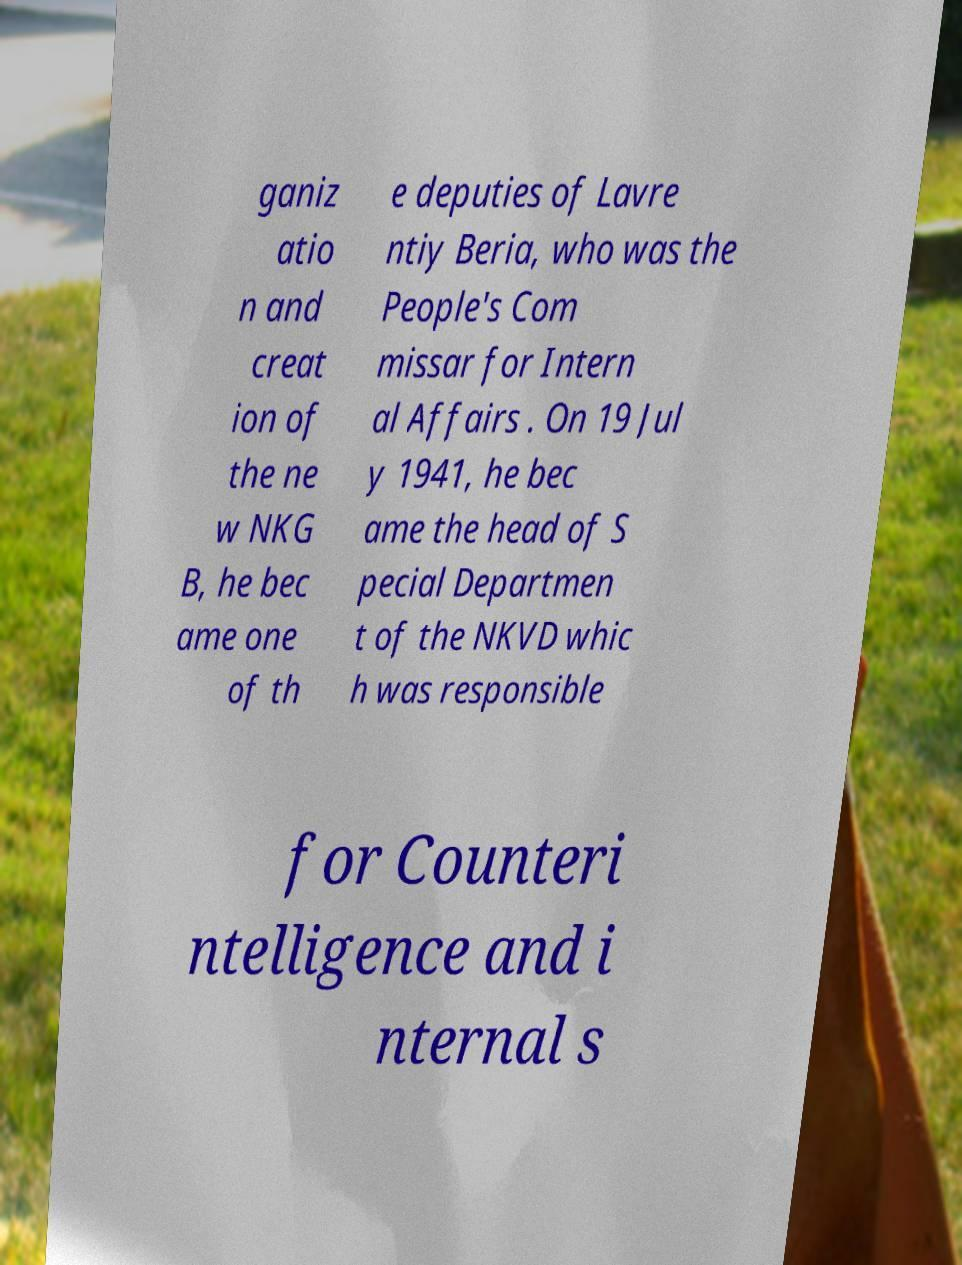Could you extract and type out the text from this image? ganiz atio n and creat ion of the ne w NKG B, he bec ame one of th e deputies of Lavre ntiy Beria, who was the People's Com missar for Intern al Affairs . On 19 Jul y 1941, he bec ame the head of S pecial Departmen t of the NKVD whic h was responsible for Counteri ntelligence and i nternal s 